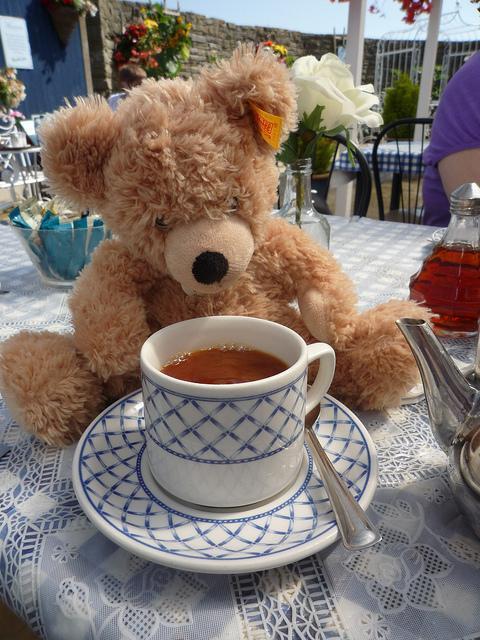Where does the teddy bear come from?
Select the accurate answer and provide justification: `Answer: choice
Rationale: srationale.`
Options: France, germany, britain, america. Answer: america.
Rationale: Teddy bears are named after us president teddy roosevelt. 